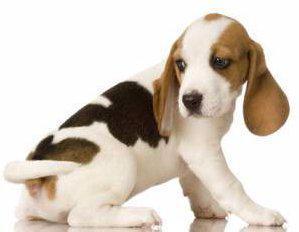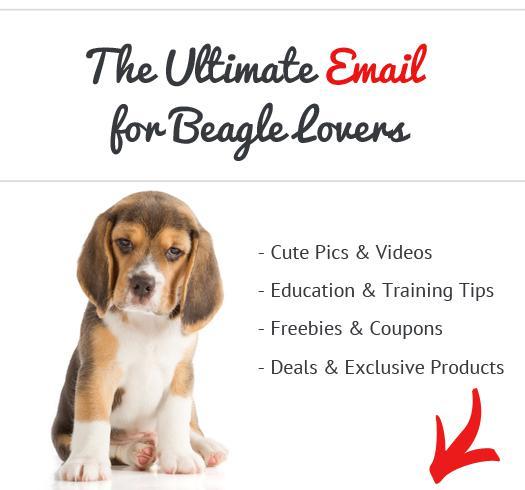The first image is the image on the left, the second image is the image on the right. Evaluate the accuracy of this statement regarding the images: "The dog is looking left, in the image to the left.". Is it true? Answer yes or no. Yes. The first image is the image on the left, the second image is the image on the right. Examine the images to the left and right. Is the description "Two dogs are sitting." accurate? Answer yes or no. Yes. 